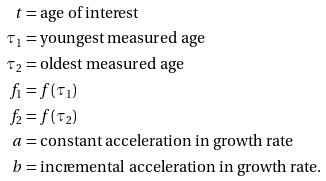Convert formula to latex. <formula><loc_0><loc_0><loc_500><loc_500>t & = \text {age of interest} \\ \tau _ { 1 } & = \text {youngest measured age} \\ \tau _ { 2 } & = \text {oldest  measured age} \\ f _ { 1 } & = f ( \tau _ { 1 } ) \\ f _ { 2 } & = f ( \tau _ { 2 } ) \\ a & = \text {constant acceleration in growth rate} \\ b & = \text {incremental acceleration in growth rate.}</formula> 